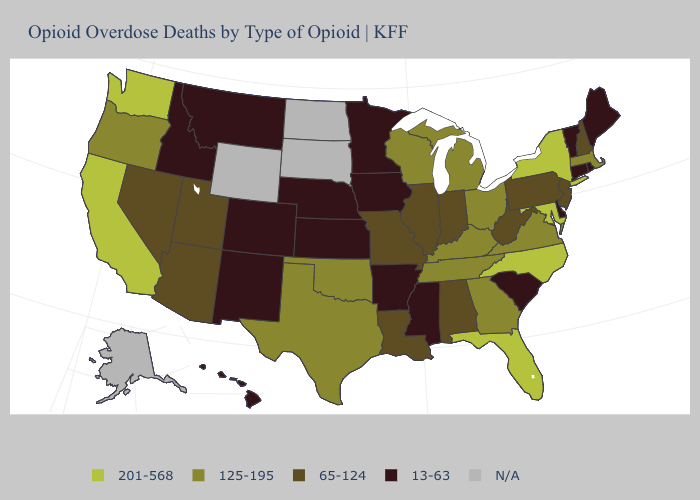Among the states that border Idaho , which have the highest value?
Concise answer only. Washington. Which states have the lowest value in the USA?
Quick response, please. Arkansas, Colorado, Connecticut, Delaware, Hawaii, Idaho, Iowa, Kansas, Maine, Minnesota, Mississippi, Montana, Nebraska, New Mexico, Rhode Island, South Carolina, Vermont. Does South Carolina have the lowest value in the South?
Quick response, please. Yes. Name the states that have a value in the range 125-195?
Concise answer only. Georgia, Kentucky, Massachusetts, Michigan, Ohio, Oklahoma, Oregon, Tennessee, Texas, Virginia, Wisconsin. Name the states that have a value in the range 65-124?
Give a very brief answer. Alabama, Arizona, Illinois, Indiana, Louisiana, Missouri, Nevada, New Hampshire, New Jersey, Pennsylvania, Utah, West Virginia. Name the states that have a value in the range 125-195?
Short answer required. Georgia, Kentucky, Massachusetts, Michigan, Ohio, Oklahoma, Oregon, Tennessee, Texas, Virginia, Wisconsin. Name the states that have a value in the range 201-568?
Answer briefly. California, Florida, Maryland, New York, North Carolina, Washington. Name the states that have a value in the range 125-195?
Keep it brief. Georgia, Kentucky, Massachusetts, Michigan, Ohio, Oklahoma, Oregon, Tennessee, Texas, Virginia, Wisconsin. Among the states that border Massachusetts , does Rhode Island have the highest value?
Keep it brief. No. Among the states that border Michigan , does Ohio have the lowest value?
Give a very brief answer. No. What is the highest value in states that border Indiana?
Answer briefly. 125-195. Name the states that have a value in the range 65-124?
Give a very brief answer. Alabama, Arizona, Illinois, Indiana, Louisiana, Missouri, Nevada, New Hampshire, New Jersey, Pennsylvania, Utah, West Virginia. Name the states that have a value in the range 65-124?
Answer briefly. Alabama, Arizona, Illinois, Indiana, Louisiana, Missouri, Nevada, New Hampshire, New Jersey, Pennsylvania, Utah, West Virginia. Which states hav the highest value in the Northeast?
Concise answer only. New York. 